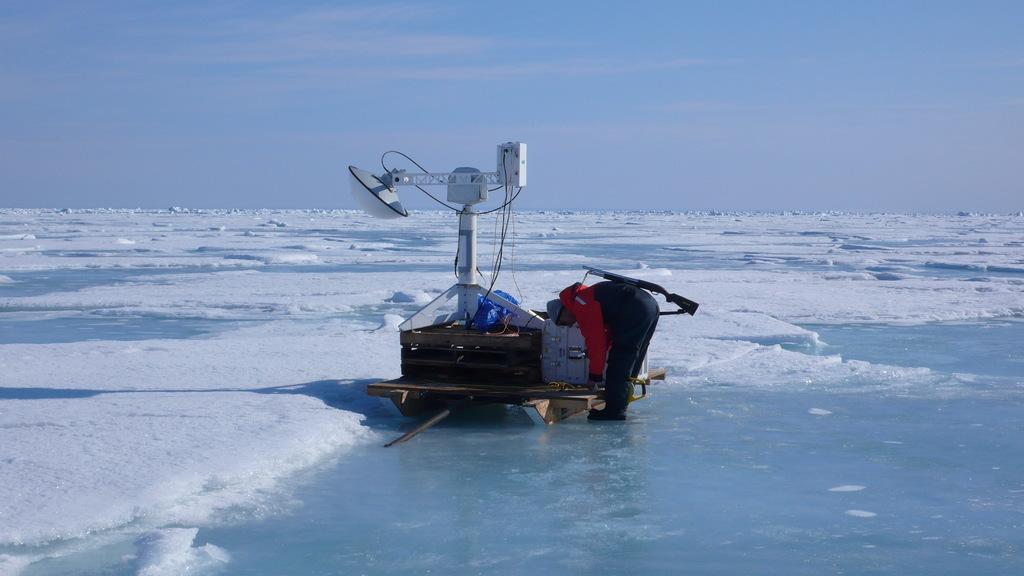What is the predominant weather condition in the image? There is snow in the image, indicating a cold and wintry condition. What else can be seen in the image besides the snow? There is water visible in the image, as well as a wooden surface with a box on it, wires, and a man standing in front of the wooden surface. What is the sky like in the image? The sky is visible in the image, but no specific details about its appearance are mentioned in the facts. Can you describe the wooden surface and the object on it? There is a wooden surface with a box on it in the image. How does the man plough the snow in the image? There is no mention of a plough or any ploughing activity in the image. --- Facts: 1. There is a person in the image. 2. The person is wearing a hat. 3. The person is holding a book. 4. The person is sitting on a chair. 5. There is a table in the image. Absurd Topics: elephant, parrot, monkey Conversation: How many people are in the image? There is one person in the image. What is the person wearing in the image? The person is wearing a hat in the image. What is the person holding in the image? The person is holding a book in the image. What is the person doing in the image? The person is sitting on a chair in the image. What other objects can be seen in the image? There is a table in the image. Reasoning: Let's think step by step in order to produce the conversation. We start by identifying the main subject in the image, which is the person. Then, we describe specific details about the person, such as the hat and the book they are holding. Next, we observe the person's actions, noting that they are sitting on a chair. Finally, we describe any other objects present in the image, such as the table. Absurd Question/Answer: How many elephants are in the image? There are no elephants present in the image. --- Facts: 1. There is a dog in the image. 2. The dog is lying down on the grass. 3. The dog is wagging its tail. 4. There is a tree in the background of the image. 5. The sky is visible in the image. Absurd Topics: giraffe, lion, tiger Conversation: What type of animal is in the image? There is a dog in the image. What is the dog doing in the image? The dog is lying down on the grass in the image. What is the dog's body language in the image? The dog is wagging its tail in the image. 